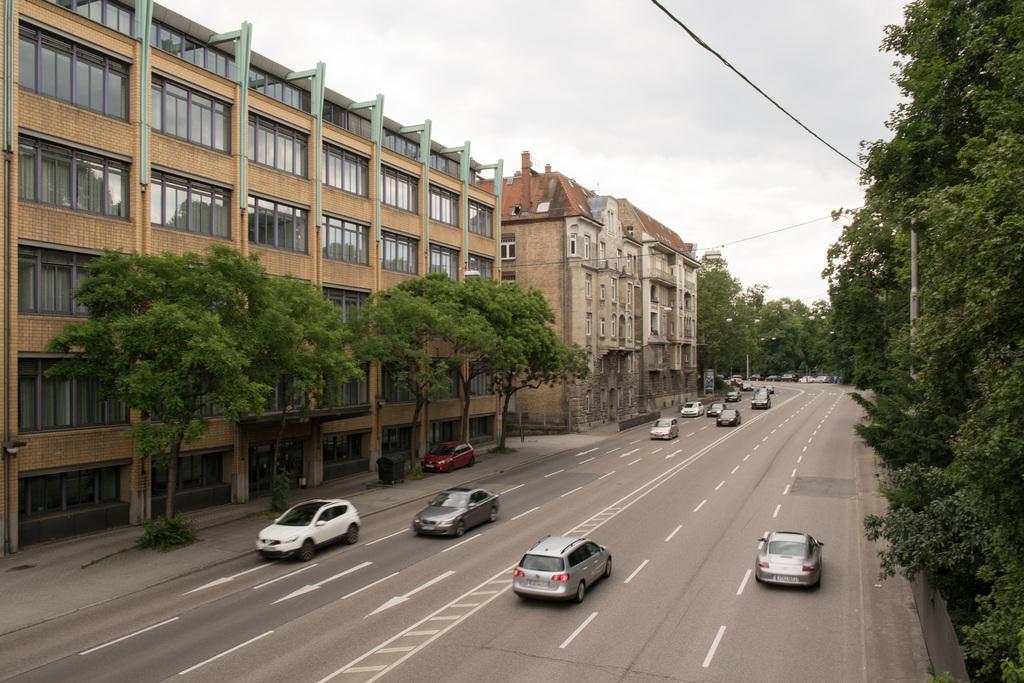In one or two sentences, can you explain what this image depicts? In the image there are many cars going on the road with trees on either side of it and buildings in the back and above its sky. 